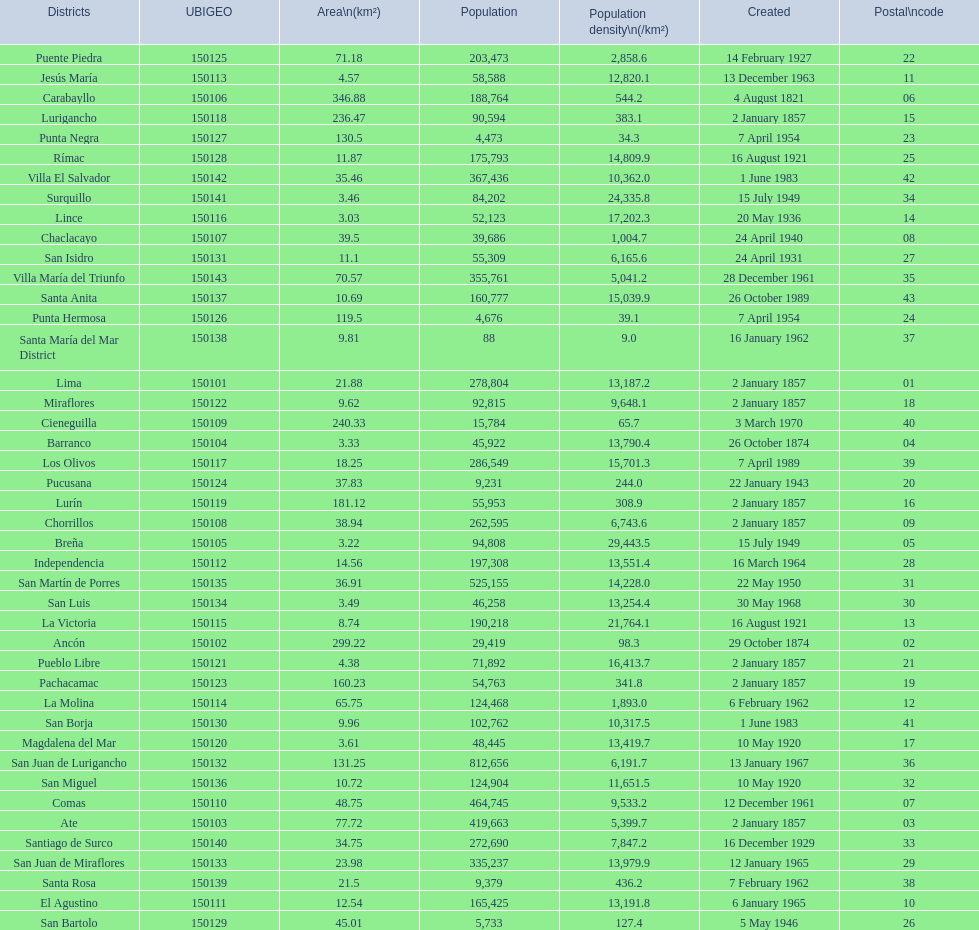Which district in this city has the greatest population? San Juan de Lurigancho. 